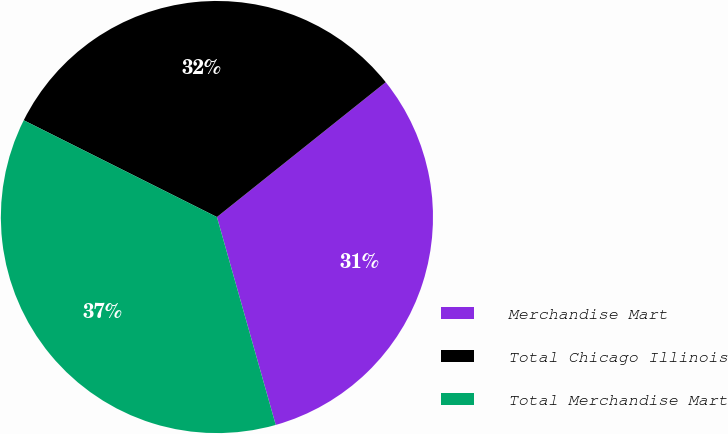Convert chart to OTSL. <chart><loc_0><loc_0><loc_500><loc_500><pie_chart><fcel>Merchandise Mart<fcel>Total Chicago Illinois<fcel>Total Merchandise Mart<nl><fcel>31.34%<fcel>31.88%<fcel>36.78%<nl></chart> 